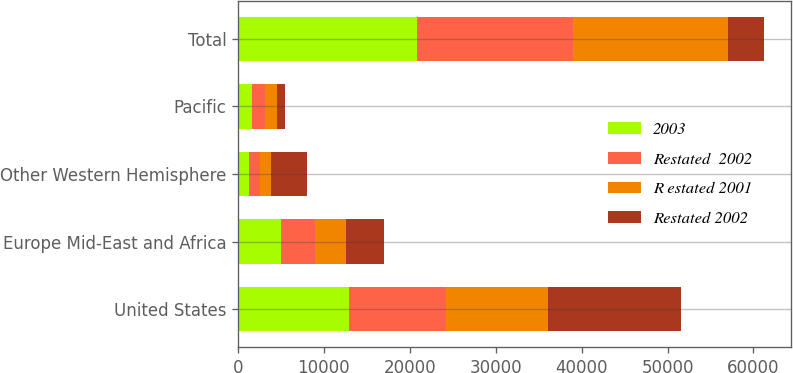<chart> <loc_0><loc_0><loc_500><loc_500><stacked_bar_chart><ecel><fcel>United States<fcel>Europe Mid-East and Africa<fcel>Other Western Hemisphere<fcel>Pacific<fcel>Total<nl><fcel>2003<fcel>12897<fcel>4985<fcel>1333<fcel>1679<fcel>20894<nl><fcel>Restated  2002<fcel>11348<fcel>4041<fcel>1215<fcel>1502<fcel>18106<nl><fcel>R estated 2001<fcel>11802<fcel>3606<fcel>1289<fcel>1347<fcel>18044<nl><fcel>Restated 2002<fcel>15560<fcel>4313<fcel>4204<fcel>945<fcel>4204<nl></chart> 